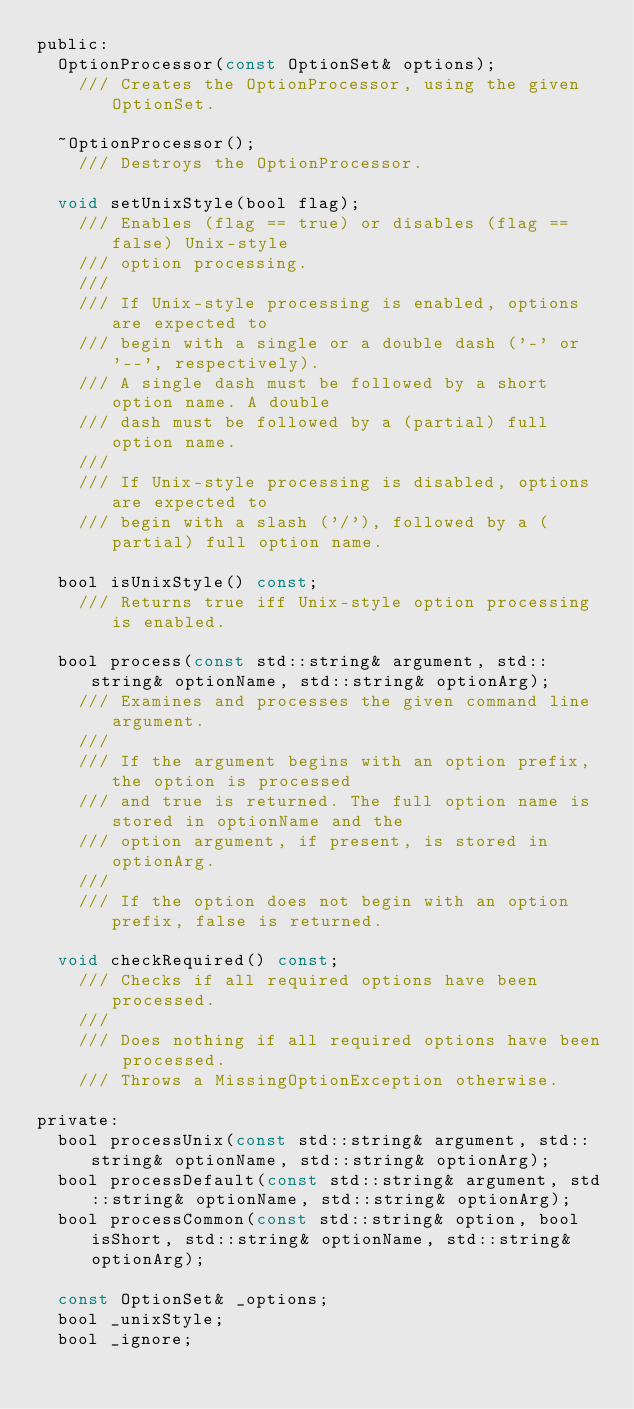Convert code to text. <code><loc_0><loc_0><loc_500><loc_500><_C_>public:
	OptionProcessor(const OptionSet& options);
		/// Creates the OptionProcessor, using the given OptionSet.

	~OptionProcessor();
		/// Destroys the OptionProcessor.

	void setUnixStyle(bool flag);
		/// Enables (flag == true) or disables (flag == false) Unix-style
		/// option processing.
		///
		/// If Unix-style processing is enabled, options are expected to
		/// begin with a single or a double dash ('-' or '--', respectively).
		/// A single dash must be followed by a short option name. A double
		/// dash must be followed by a (partial) full option name.
		///
		/// If Unix-style processing is disabled, options are expected to
		/// begin with a slash ('/'), followed by a (partial) full option name.

	bool isUnixStyle() const;
		/// Returns true iff Unix-style option processing is enabled.

	bool process(const std::string& argument, std::string& optionName, std::string& optionArg);
		/// Examines and processes the given command line argument.
		///
		/// If the argument begins with an option prefix, the option is processed
		/// and true is returned. The full option name is stored in optionName and the 
		/// option argument, if present, is stored in optionArg.
		///
		/// If the option does not begin with an option prefix, false is returned.

	void checkRequired() const;
		/// Checks if all required options have been processed.
		///
		/// Does nothing if all required options have been processed.
		/// Throws a MissingOptionException otherwise.

private:
	bool processUnix(const std::string& argument, std::string& optionName, std::string& optionArg);
	bool processDefault(const std::string& argument, std::string& optionName, std::string& optionArg);
	bool processCommon(const std::string& option, bool isShort, std::string& optionName, std::string& optionArg);
	
	const OptionSet& _options;
	bool _unixStyle;
	bool _ignore;</code> 